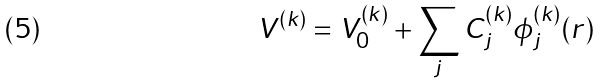<formula> <loc_0><loc_0><loc_500><loc_500>V ^ { ( k ) } = V _ { 0 } ^ { ( k ) } + \sum _ { j } C ^ { ( k ) } _ { j } \phi ^ { ( k ) } _ { j } ( r )</formula> 